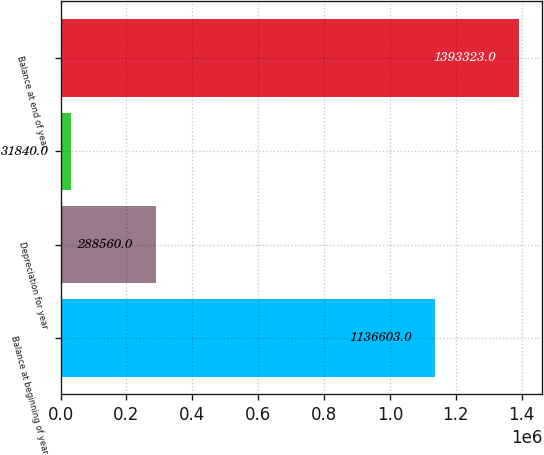Convert chart to OTSL. <chart><loc_0><loc_0><loc_500><loc_500><bar_chart><fcel>Balance at beginning of year<fcel>Depreciation for year<fcel>Unnamed: 2<fcel>Balance at end of year<nl><fcel>1.1366e+06<fcel>288560<fcel>31840<fcel>1.39332e+06<nl></chart> 